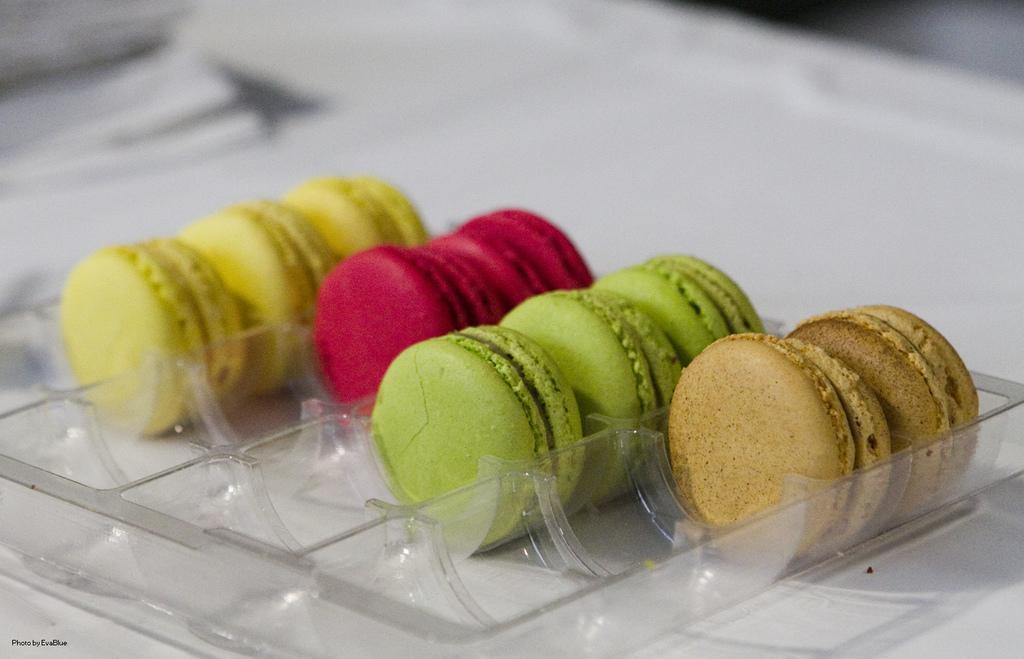Please provide a concise description of this image. In the picture there are few cookies kept in a tray, they are of different colors and the background of the cookies is blur. 